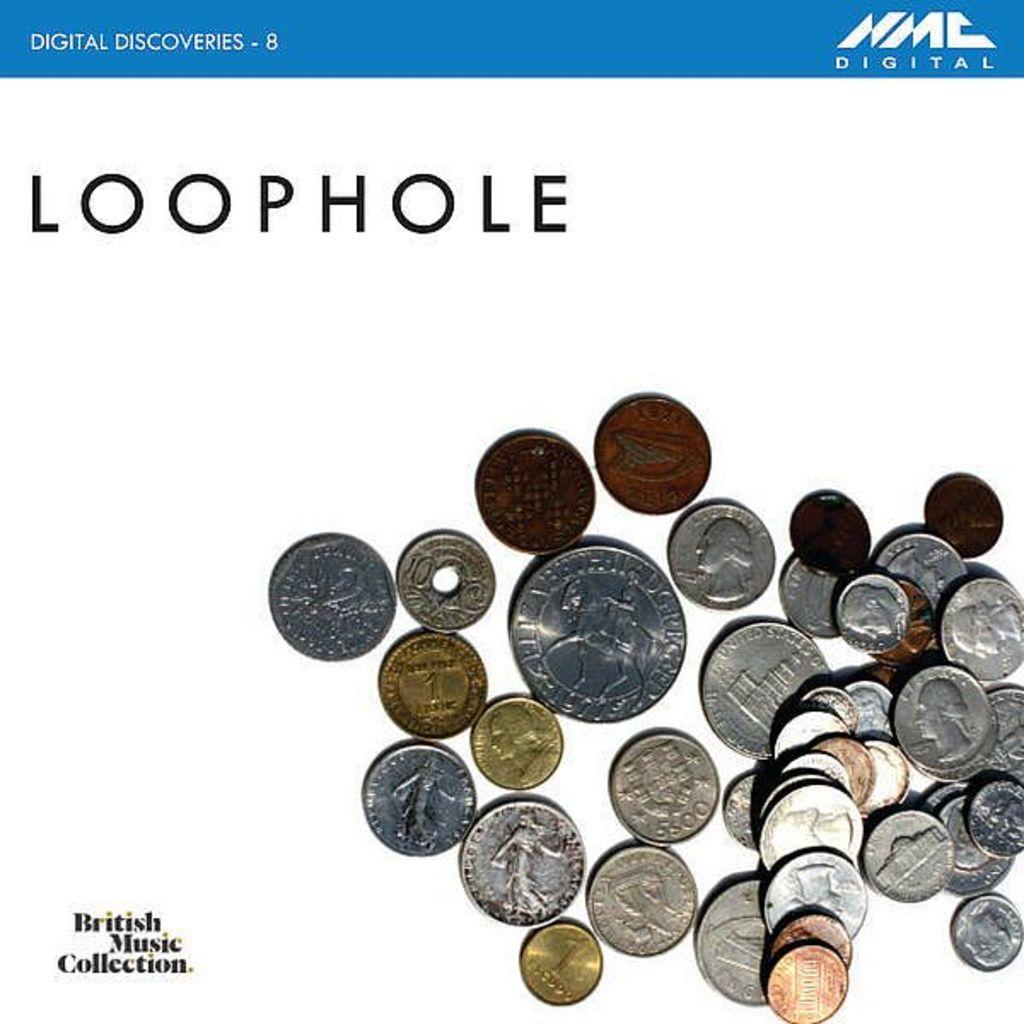Are these types of coins currently in monetary circulation?
Provide a short and direct response. Unanswerable. Did loophole make this picture?
Keep it short and to the point. Yes. 